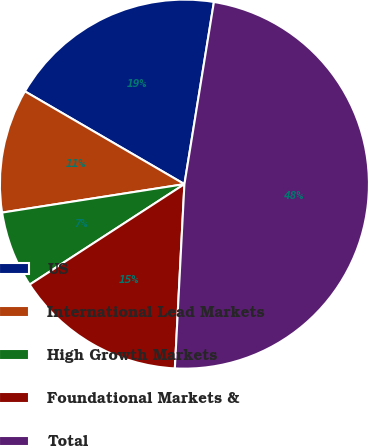Convert chart to OTSL. <chart><loc_0><loc_0><loc_500><loc_500><pie_chart><fcel>US<fcel>International Lead Markets<fcel>High Growth Markets<fcel>Foundational Markets &<fcel>Total<nl><fcel>19.17%<fcel>10.85%<fcel>6.7%<fcel>15.01%<fcel>48.27%<nl></chart> 